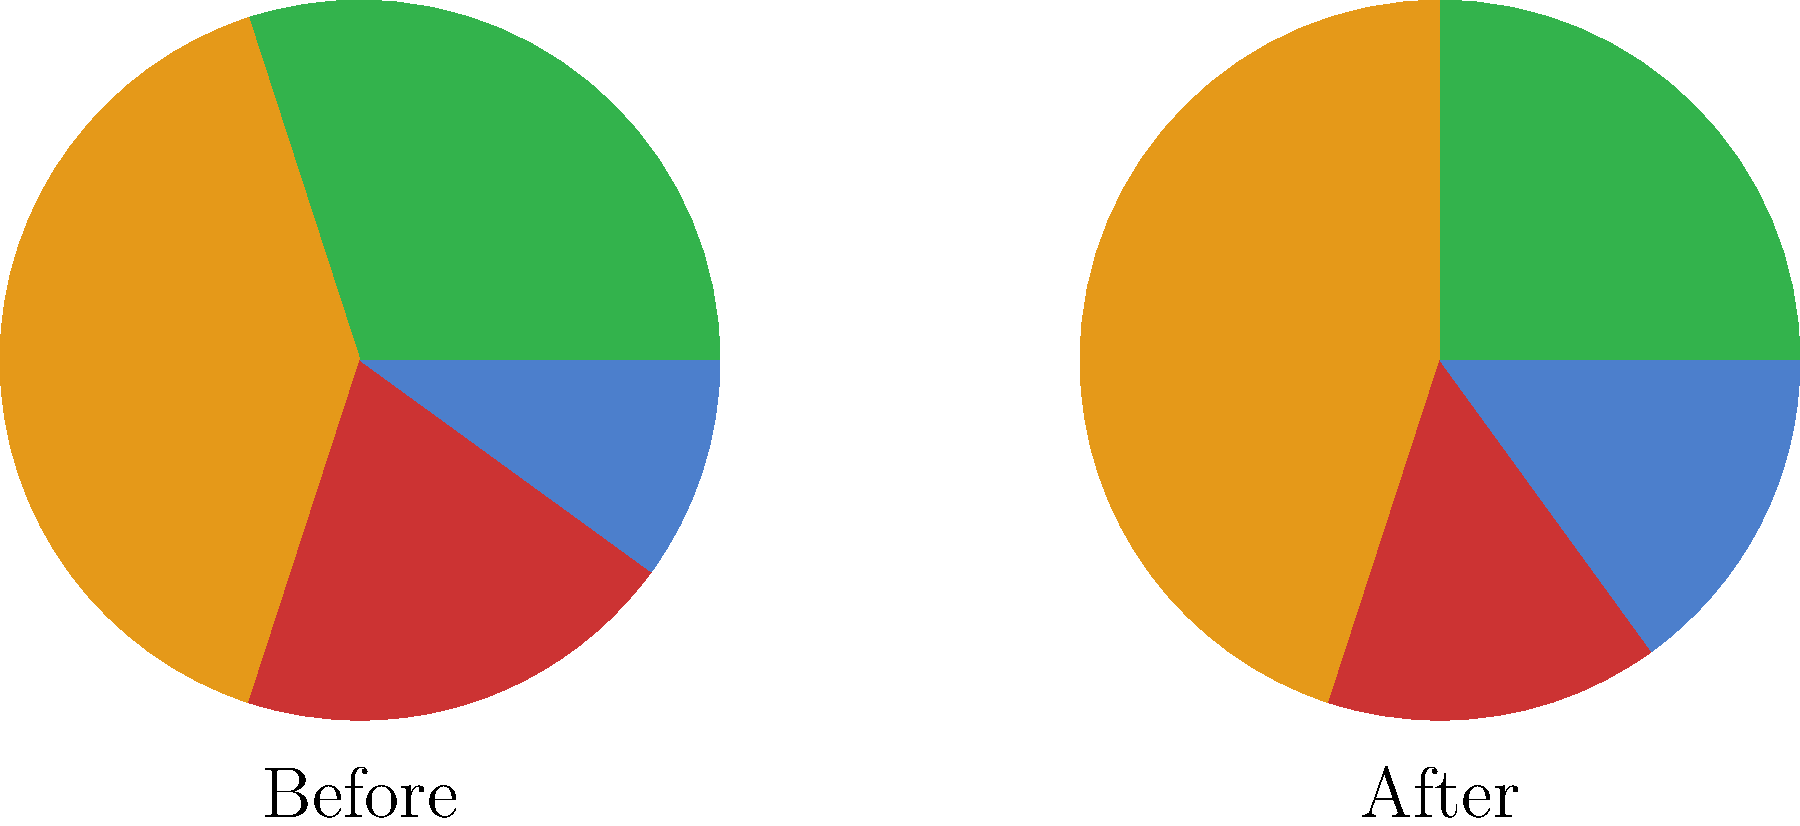Based on the nutritional strategy changes depicted in the pie charts and bar graphs, which macronutrient showed the most significant increase in percentage, and how might this impact a female professional weightlifter's performance in preparation for the World Weightlifting Championships? To answer this question, let's analyze the data step-by-step:

1. Examine the pie charts and bar graphs to identify changes in macronutrient distribution:
   - Protein: Decreased from 30% to 25%
   - Carbohydrates: Increased from 40% to 45%
   - Fat: Decreased from 20% to 15%
   - Supplements: Increased from 10% to 15%

2. Identify the macronutrient with the most significant increase:
   Carbohydrates showed the largest increase, from 40% to 45% (a 5% increase).

3. Consider the impact of increased carbohydrate intake on a female professional weightlifter:
   a. Energy availability: Carbohydrates are the primary source of energy for high-intensity activities like weightlifting.
   b. Glycogen storage: Increased carb intake can lead to higher muscle glycogen stores, which is crucial for explosive movements and sustained training sessions.
   c. Recovery: Adequate carbohydrate intake aids in post-workout recovery and muscle glycogen replenishment.
   d. Muscle preservation: Sufficient carb intake can help spare muscle protein from being used as energy, supporting muscle maintenance and growth.

4. Potential benefits for World Weightlifting Championships preparation:
   a. Improved power output: Higher glycogen stores can enhance explosive strength needed for successful lifts.
   b. Increased training capacity: More available energy allows for higher training volume and intensity.
   c. Enhanced recovery: Faster recovery between training sessions and competition attempts.
   d. Weight management: Carbohydrate manipulation can assist in making weight classes while maintaining performance.

5. Considerations:
   - The decrease in protein intake (from 30% to 25%) should be monitored to ensure adequate protein for muscle repair and growth.
   - The increase in supplement use (from 10% to 15%) may indicate a more targeted approach to nutrition, potentially including performance-enhancing supplements within competition regulations.
Answer: Carbohydrates increased most (5%), likely improving energy availability, power output, and recovery for the weightlifter. 